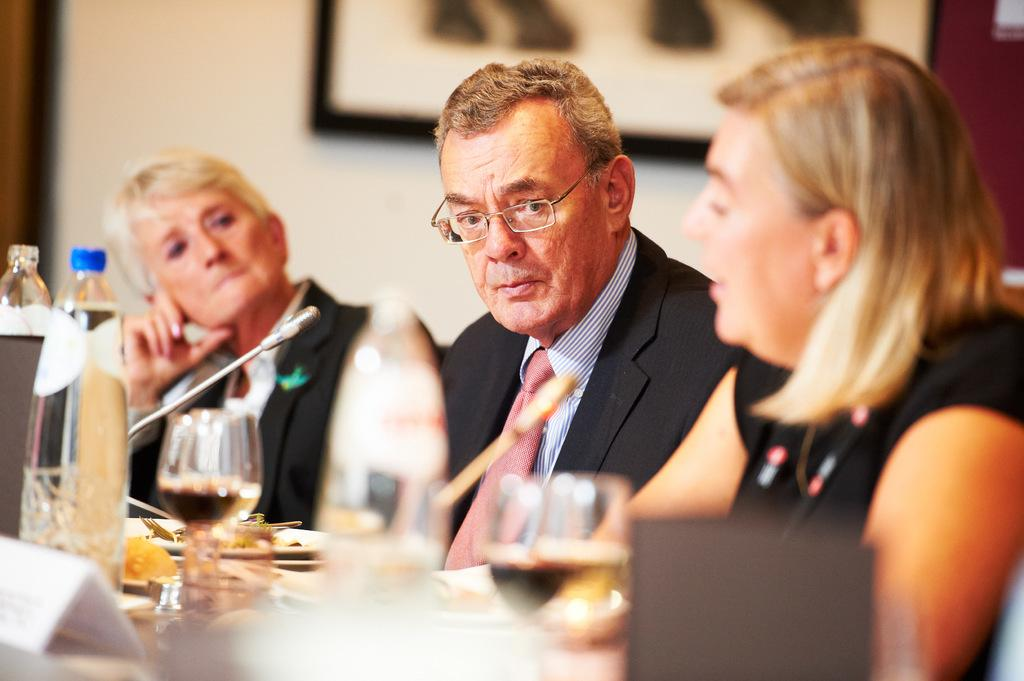Who or what can be seen in the image? There are people in the image. What is on the table in the image? There are many objects on the table. What is hanging on the wall in the image? There is a photo on the wall. What device is present in the image for amplifying sound? There is a microphone in the image. What type of country is depicted in the image? There is no country depicted in the image; it features people, objects, and a photo on the wall. How many beans are visible in the image? There are no beans present in the image. 